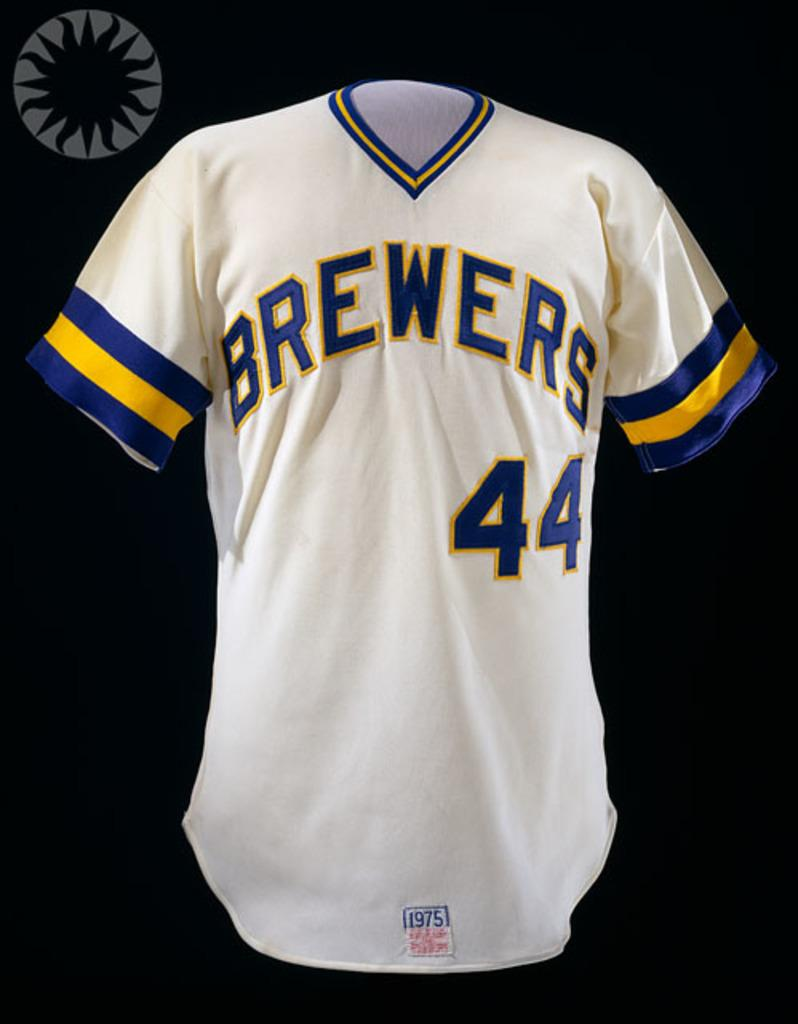<image>
Summarize the visual content of the image. A Milwaukee brewers jersey with the number 44. 